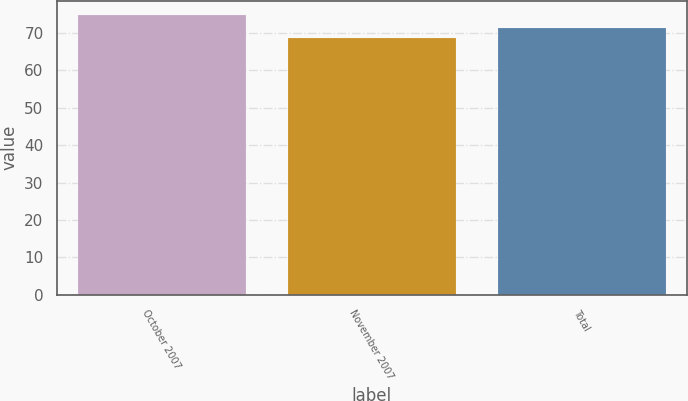Convert chart. <chart><loc_0><loc_0><loc_500><loc_500><bar_chart><fcel>October 2007<fcel>November 2007<fcel>Total<nl><fcel>74.89<fcel>68.6<fcel>71.23<nl></chart> 